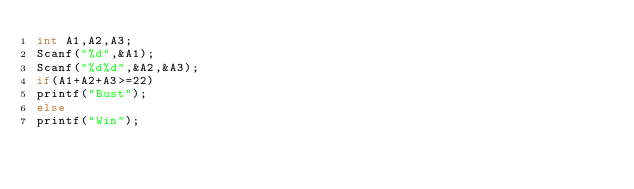Convert code to text. <code><loc_0><loc_0><loc_500><loc_500><_C_>int A1,A2,A3;
Scanf("%d",&A1);
Scanf("%d%d",&A2,&A3);
if(A1+A2+A3>=22)
printf("Bust");
else
printf("Win"); </code> 